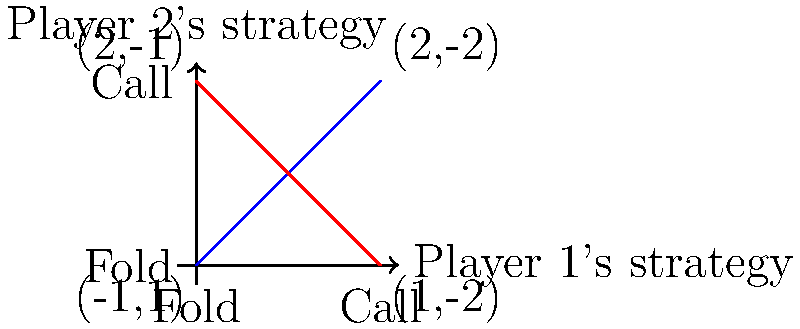In a simplified two-player poker variant, players must either fold or call. The payoff matrix for this game is shown in the graph, where the first number in each pair represents Player 1's payoff and the second number represents Player 2's payoff. Using game theory concepts, what is the optimal mixed strategy for Player 1, expressed as the probability of calling? To find the optimal mixed strategy for Player 1, we'll use the concept of mixed strategy Nash equilibrium:

1. Let $p$ be the probability that Player 1 calls, and $1-p$ be the probability that Player 1 folds.

2. For Player 2, let $q$ be the probability of calling, and $1-q$ be the probability of folding.

3. Player 2's expected payoff when folding:
   $E_2(fold) = 1p + 1(1-p) = 1$

4. Player 2's expected payoff when calling:
   $E_2(call) = -2p + (-1)(1-p) = -2p - 1 + p = -p - 1$

5. For mixed strategy equilibrium, these should be equal:
   $1 = -p - 1$
   $2 = -p$
   $p = \frac{2}{3}$

6. To verify, we can calculate Player 1's expected payoffs:
   $E_1(fold) = -1q + 2(1-q) = 2 - 3q$
   $E_1(call) = 2q + 1(1-q) = 1 + q$

7. Setting these equal:
   $2 - 3q = 1 + q$
   $1 = 4q$
   $q = \frac{1}{4}$

8. This confirms that when Player 2 uses the optimal strategy of calling with probability $\frac{1}{4}$, Player 1 is indifferent between folding and calling, validating our solution.

Therefore, Player 1's optimal strategy is to call with probability $\frac{2}{3}$ and fold with probability $\frac{1}{3}$.
Answer: $\frac{2}{3}$ 